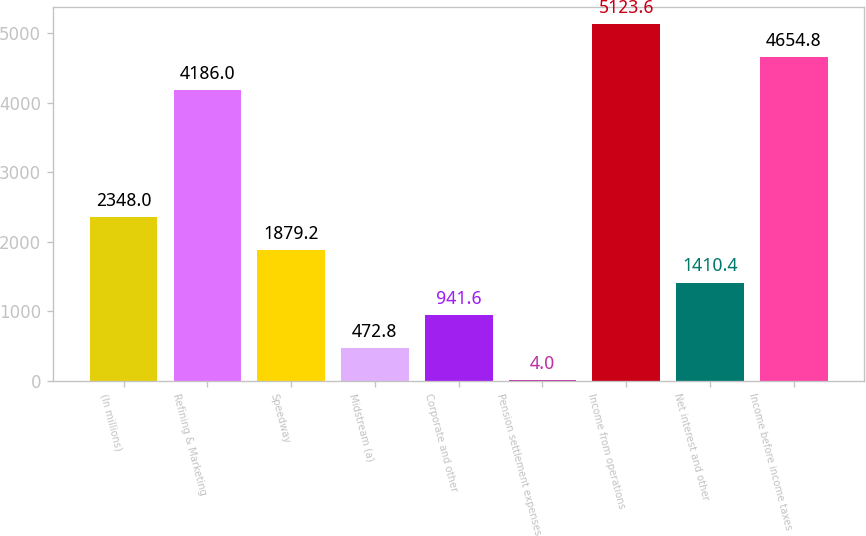<chart> <loc_0><loc_0><loc_500><loc_500><bar_chart><fcel>(In millions)<fcel>Refining & Marketing<fcel>Speedway<fcel>Midstream (a)<fcel>Corporate and other<fcel>Pension settlement expenses<fcel>Income from operations<fcel>Net interest and other<fcel>Income before income taxes<nl><fcel>2348<fcel>4186<fcel>1879.2<fcel>472.8<fcel>941.6<fcel>4<fcel>5123.6<fcel>1410.4<fcel>4654.8<nl></chart> 